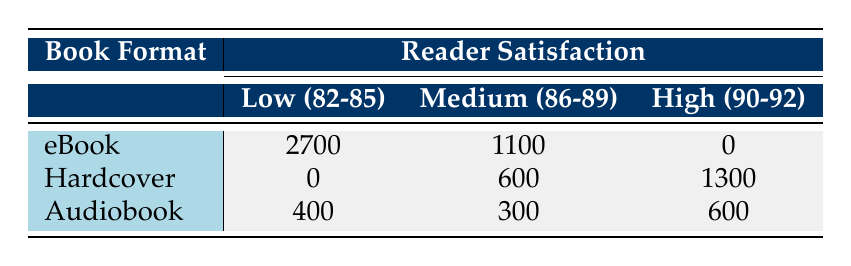What is the total number of readers who reported low satisfaction for eBooks? According to the table, eBooks had 2700 readers reporting low satisfaction. This number is directly retrieved from the "Low (82-85)" column under the eBook row.
Answer: 2700 How many readers rated their satisfaction as high for audiobooks? The table states that audiobooks had 600 readers who rated their satisfaction as high. This can be found in the "High (90-92)" column under the Audiobook row.
Answer: 600 Is there any book format that received no low satisfaction ratings? Yes, the table shows that both Hardcover and eBook formats have 0 counts for low satisfaction ratings, meaning they did not receive any low ratings.
Answer: Yes What is the total number of readers who had medium satisfaction across all formats? The total number of medium satisfaction readers can be calculated by adding the medium satisfaction counts for each format: eBook (1100) + Hardcover (600) + Audiobook (300) = 2000.
Answer: 2000 Which book format has the highest number of readers reporting high satisfaction? The Hardcover format has the highest number of readers reporting high satisfaction, with a count of 1300, as seen in the "High (90-92)" column under the Hardcover row.
Answer: Hardcover What is the average satisfaction rating for the Hardcover format based on the data provided? To find the average satisfaction for the Hardcover format, we need to calculate a weighted average. We multiply the satisfaction ratings by their counts: (90 * 800 + 92 * 500) / (800 + 500) = 90.67. Therefore, the average satisfaction rating for the Hardcover format is approximately 90.67.
Answer: 90.67 Which book format shows the lowest medium satisfaction count? The Audiobook format shows the lowest medium satisfaction count, with 300 readers, as can be seen in the table under the "Medium (86-89)" column for the Audiobook row.
Answer: Audiobook How does the low satisfaction count for audiobooks compare to that of eBooks? The low satisfaction count for audiobooks is 400, while for eBooks it is 2700. Comparing these figures: 2700 (eBooks) - 400 (Audiobooks) = 2300. Therefore, eBooks have 2300 more low satisfaction ratings than audiobooks.
Answer: 2300 